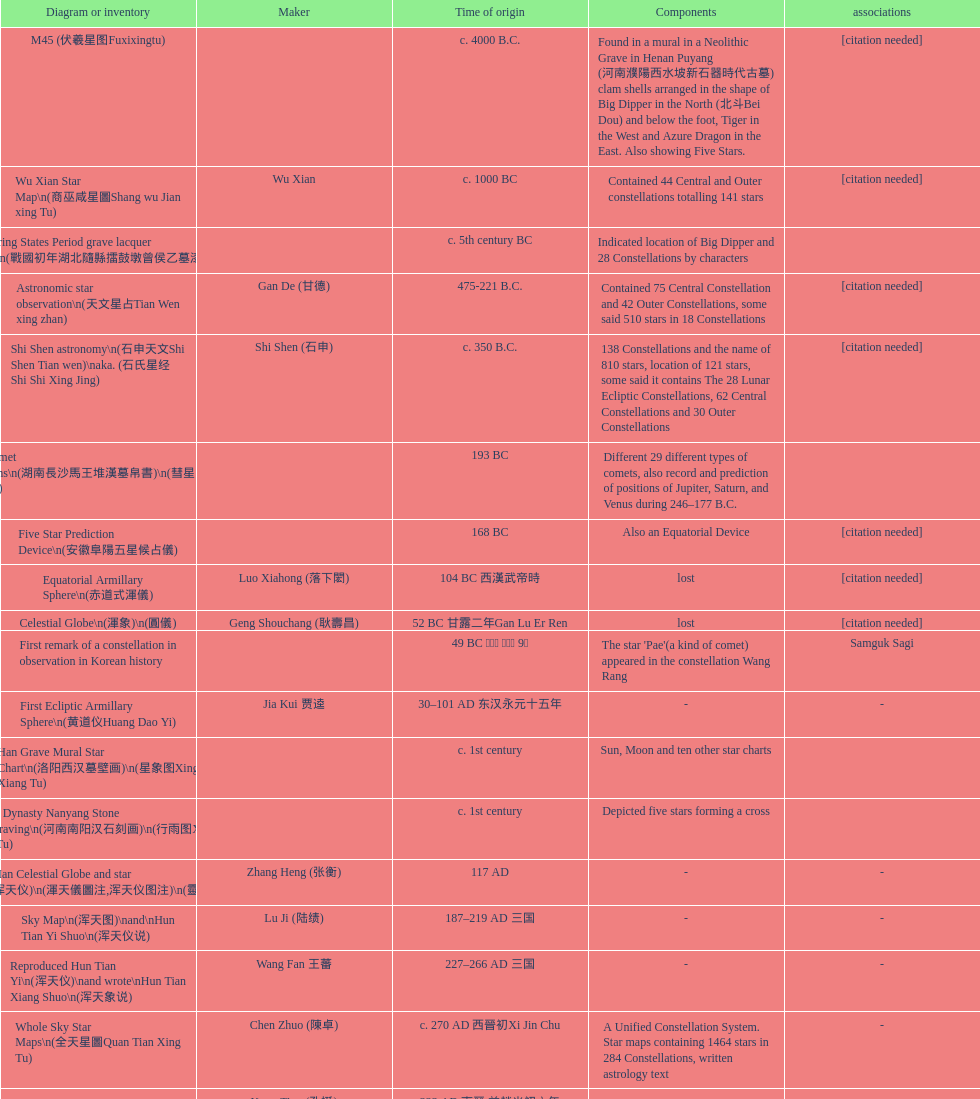Which map or catalog was created last? Sky in Google Earth KML. 